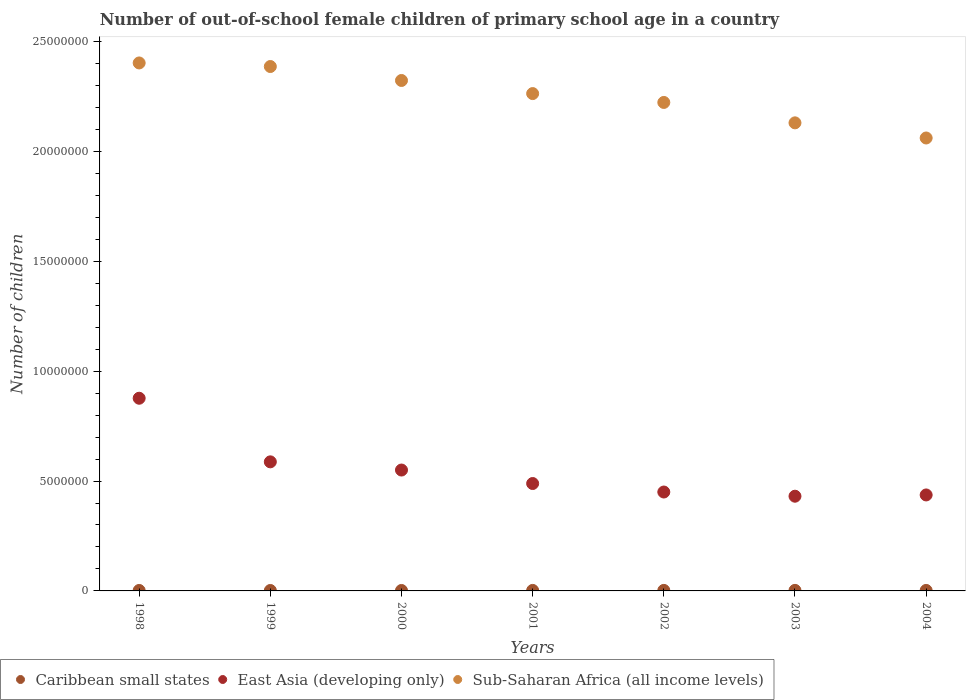How many different coloured dotlines are there?
Keep it short and to the point. 3. What is the number of out-of-school female children in East Asia (developing only) in 1999?
Ensure brevity in your answer.  5.87e+06. Across all years, what is the maximum number of out-of-school female children in Caribbean small states?
Provide a short and direct response. 2.49e+04. Across all years, what is the minimum number of out-of-school female children in Sub-Saharan Africa (all income levels)?
Make the answer very short. 2.06e+07. In which year was the number of out-of-school female children in Caribbean small states maximum?
Provide a succinct answer. 2003. In which year was the number of out-of-school female children in Sub-Saharan Africa (all income levels) minimum?
Your response must be concise. 2004. What is the total number of out-of-school female children in Sub-Saharan Africa (all income levels) in the graph?
Your answer should be very brief. 1.58e+08. What is the difference between the number of out-of-school female children in Sub-Saharan Africa (all income levels) in 2003 and that in 2004?
Your answer should be very brief. 6.89e+05. What is the difference between the number of out-of-school female children in Caribbean small states in 1998 and the number of out-of-school female children in East Asia (developing only) in 2000?
Your response must be concise. -5.48e+06. What is the average number of out-of-school female children in Sub-Saharan Africa (all income levels) per year?
Offer a very short reply. 2.26e+07. In the year 1999, what is the difference between the number of out-of-school female children in Sub-Saharan Africa (all income levels) and number of out-of-school female children in Caribbean small states?
Your response must be concise. 2.38e+07. What is the ratio of the number of out-of-school female children in Sub-Saharan Africa (all income levels) in 1999 to that in 2004?
Ensure brevity in your answer.  1.16. What is the difference between the highest and the second highest number of out-of-school female children in East Asia (developing only)?
Ensure brevity in your answer.  2.89e+06. What is the difference between the highest and the lowest number of out-of-school female children in East Asia (developing only)?
Your response must be concise. 4.46e+06. How many years are there in the graph?
Ensure brevity in your answer.  7. Are the values on the major ticks of Y-axis written in scientific E-notation?
Offer a terse response. No. Does the graph contain any zero values?
Your answer should be compact. No. Where does the legend appear in the graph?
Provide a succinct answer. Bottom left. How many legend labels are there?
Provide a succinct answer. 3. How are the legend labels stacked?
Offer a terse response. Horizontal. What is the title of the graph?
Your answer should be very brief. Number of out-of-school female children of primary school age in a country. Does "Papua New Guinea" appear as one of the legend labels in the graph?
Provide a succinct answer. No. What is the label or title of the Y-axis?
Ensure brevity in your answer.  Number of children. What is the Number of children in Caribbean small states in 1998?
Offer a very short reply. 2.08e+04. What is the Number of children in East Asia (developing only) in 1998?
Your answer should be very brief. 8.77e+06. What is the Number of children of Sub-Saharan Africa (all income levels) in 1998?
Give a very brief answer. 2.40e+07. What is the Number of children of Caribbean small states in 1999?
Your answer should be compact. 1.98e+04. What is the Number of children in East Asia (developing only) in 1999?
Keep it short and to the point. 5.87e+06. What is the Number of children of Sub-Saharan Africa (all income levels) in 1999?
Your answer should be compact. 2.39e+07. What is the Number of children of Caribbean small states in 2000?
Provide a succinct answer. 2.00e+04. What is the Number of children of East Asia (developing only) in 2000?
Ensure brevity in your answer.  5.50e+06. What is the Number of children in Sub-Saharan Africa (all income levels) in 2000?
Provide a succinct answer. 2.32e+07. What is the Number of children of Caribbean small states in 2001?
Give a very brief answer. 2.31e+04. What is the Number of children in East Asia (developing only) in 2001?
Offer a terse response. 4.89e+06. What is the Number of children in Sub-Saharan Africa (all income levels) in 2001?
Your response must be concise. 2.26e+07. What is the Number of children in Caribbean small states in 2002?
Ensure brevity in your answer.  2.41e+04. What is the Number of children in East Asia (developing only) in 2002?
Make the answer very short. 4.50e+06. What is the Number of children of Sub-Saharan Africa (all income levels) in 2002?
Offer a terse response. 2.22e+07. What is the Number of children in Caribbean small states in 2003?
Ensure brevity in your answer.  2.49e+04. What is the Number of children in East Asia (developing only) in 2003?
Provide a succinct answer. 4.31e+06. What is the Number of children in Sub-Saharan Africa (all income levels) in 2003?
Make the answer very short. 2.13e+07. What is the Number of children in Caribbean small states in 2004?
Offer a terse response. 2.23e+04. What is the Number of children of East Asia (developing only) in 2004?
Your answer should be compact. 4.37e+06. What is the Number of children in Sub-Saharan Africa (all income levels) in 2004?
Ensure brevity in your answer.  2.06e+07. Across all years, what is the maximum Number of children of Caribbean small states?
Your response must be concise. 2.49e+04. Across all years, what is the maximum Number of children of East Asia (developing only)?
Provide a succinct answer. 8.77e+06. Across all years, what is the maximum Number of children in Sub-Saharan Africa (all income levels)?
Your answer should be compact. 2.40e+07. Across all years, what is the minimum Number of children of Caribbean small states?
Offer a terse response. 1.98e+04. Across all years, what is the minimum Number of children in East Asia (developing only)?
Provide a succinct answer. 4.31e+06. Across all years, what is the minimum Number of children of Sub-Saharan Africa (all income levels)?
Give a very brief answer. 2.06e+07. What is the total Number of children of Caribbean small states in the graph?
Ensure brevity in your answer.  1.55e+05. What is the total Number of children in East Asia (developing only) in the graph?
Provide a short and direct response. 3.82e+07. What is the total Number of children in Sub-Saharan Africa (all income levels) in the graph?
Offer a very short reply. 1.58e+08. What is the difference between the Number of children of Caribbean small states in 1998 and that in 1999?
Offer a very short reply. 1053. What is the difference between the Number of children of East Asia (developing only) in 1998 and that in 1999?
Provide a short and direct response. 2.89e+06. What is the difference between the Number of children in Sub-Saharan Africa (all income levels) in 1998 and that in 1999?
Provide a short and direct response. 1.62e+05. What is the difference between the Number of children of Caribbean small states in 1998 and that in 2000?
Keep it short and to the point. 776. What is the difference between the Number of children of East Asia (developing only) in 1998 and that in 2000?
Offer a terse response. 3.27e+06. What is the difference between the Number of children of Sub-Saharan Africa (all income levels) in 1998 and that in 2000?
Make the answer very short. 7.98e+05. What is the difference between the Number of children in Caribbean small states in 1998 and that in 2001?
Provide a short and direct response. -2341. What is the difference between the Number of children in East Asia (developing only) in 1998 and that in 2001?
Keep it short and to the point. 3.88e+06. What is the difference between the Number of children in Sub-Saharan Africa (all income levels) in 1998 and that in 2001?
Make the answer very short. 1.39e+06. What is the difference between the Number of children in Caribbean small states in 1998 and that in 2002?
Your answer should be very brief. -3301. What is the difference between the Number of children in East Asia (developing only) in 1998 and that in 2002?
Your answer should be compact. 4.27e+06. What is the difference between the Number of children of Sub-Saharan Africa (all income levels) in 1998 and that in 2002?
Make the answer very short. 1.80e+06. What is the difference between the Number of children in Caribbean small states in 1998 and that in 2003?
Provide a succinct answer. -4129. What is the difference between the Number of children of East Asia (developing only) in 1998 and that in 2003?
Provide a succinct answer. 4.46e+06. What is the difference between the Number of children in Sub-Saharan Africa (all income levels) in 1998 and that in 2003?
Your answer should be compact. 2.73e+06. What is the difference between the Number of children in Caribbean small states in 1998 and that in 2004?
Make the answer very short. -1502. What is the difference between the Number of children in East Asia (developing only) in 1998 and that in 2004?
Provide a short and direct response. 4.40e+06. What is the difference between the Number of children in Sub-Saharan Africa (all income levels) in 1998 and that in 2004?
Ensure brevity in your answer.  3.41e+06. What is the difference between the Number of children of Caribbean small states in 1999 and that in 2000?
Your response must be concise. -277. What is the difference between the Number of children of East Asia (developing only) in 1999 and that in 2000?
Provide a short and direct response. 3.73e+05. What is the difference between the Number of children of Sub-Saharan Africa (all income levels) in 1999 and that in 2000?
Your answer should be very brief. 6.35e+05. What is the difference between the Number of children in Caribbean small states in 1999 and that in 2001?
Offer a terse response. -3394. What is the difference between the Number of children of East Asia (developing only) in 1999 and that in 2001?
Make the answer very short. 9.86e+05. What is the difference between the Number of children of Sub-Saharan Africa (all income levels) in 1999 and that in 2001?
Make the answer very short. 1.23e+06. What is the difference between the Number of children in Caribbean small states in 1999 and that in 2002?
Offer a very short reply. -4354. What is the difference between the Number of children of East Asia (developing only) in 1999 and that in 2002?
Offer a very short reply. 1.37e+06. What is the difference between the Number of children of Sub-Saharan Africa (all income levels) in 1999 and that in 2002?
Offer a terse response. 1.63e+06. What is the difference between the Number of children in Caribbean small states in 1999 and that in 2003?
Provide a succinct answer. -5182. What is the difference between the Number of children in East Asia (developing only) in 1999 and that in 2003?
Offer a very short reply. 1.56e+06. What is the difference between the Number of children of Sub-Saharan Africa (all income levels) in 1999 and that in 2003?
Offer a terse response. 2.56e+06. What is the difference between the Number of children in Caribbean small states in 1999 and that in 2004?
Provide a succinct answer. -2555. What is the difference between the Number of children in East Asia (developing only) in 1999 and that in 2004?
Ensure brevity in your answer.  1.51e+06. What is the difference between the Number of children in Sub-Saharan Africa (all income levels) in 1999 and that in 2004?
Your answer should be very brief. 3.25e+06. What is the difference between the Number of children of Caribbean small states in 2000 and that in 2001?
Give a very brief answer. -3117. What is the difference between the Number of children in East Asia (developing only) in 2000 and that in 2001?
Provide a succinct answer. 6.14e+05. What is the difference between the Number of children in Sub-Saharan Africa (all income levels) in 2000 and that in 2001?
Make the answer very short. 5.96e+05. What is the difference between the Number of children in Caribbean small states in 2000 and that in 2002?
Make the answer very short. -4077. What is the difference between the Number of children in East Asia (developing only) in 2000 and that in 2002?
Offer a very short reply. 1.00e+06. What is the difference between the Number of children of Sub-Saharan Africa (all income levels) in 2000 and that in 2002?
Offer a terse response. 9.99e+05. What is the difference between the Number of children in Caribbean small states in 2000 and that in 2003?
Offer a very short reply. -4905. What is the difference between the Number of children of East Asia (developing only) in 2000 and that in 2003?
Your response must be concise. 1.19e+06. What is the difference between the Number of children of Sub-Saharan Africa (all income levels) in 2000 and that in 2003?
Provide a short and direct response. 1.93e+06. What is the difference between the Number of children in Caribbean small states in 2000 and that in 2004?
Offer a terse response. -2278. What is the difference between the Number of children of East Asia (developing only) in 2000 and that in 2004?
Keep it short and to the point. 1.13e+06. What is the difference between the Number of children of Sub-Saharan Africa (all income levels) in 2000 and that in 2004?
Offer a very short reply. 2.62e+06. What is the difference between the Number of children of Caribbean small states in 2001 and that in 2002?
Provide a short and direct response. -960. What is the difference between the Number of children in East Asia (developing only) in 2001 and that in 2002?
Provide a succinct answer. 3.87e+05. What is the difference between the Number of children of Sub-Saharan Africa (all income levels) in 2001 and that in 2002?
Make the answer very short. 4.03e+05. What is the difference between the Number of children in Caribbean small states in 2001 and that in 2003?
Keep it short and to the point. -1788. What is the difference between the Number of children in East Asia (developing only) in 2001 and that in 2003?
Ensure brevity in your answer.  5.78e+05. What is the difference between the Number of children in Sub-Saharan Africa (all income levels) in 2001 and that in 2003?
Offer a very short reply. 1.33e+06. What is the difference between the Number of children in Caribbean small states in 2001 and that in 2004?
Offer a very short reply. 839. What is the difference between the Number of children in East Asia (developing only) in 2001 and that in 2004?
Offer a terse response. 5.20e+05. What is the difference between the Number of children of Sub-Saharan Africa (all income levels) in 2001 and that in 2004?
Ensure brevity in your answer.  2.02e+06. What is the difference between the Number of children of Caribbean small states in 2002 and that in 2003?
Offer a very short reply. -828. What is the difference between the Number of children in East Asia (developing only) in 2002 and that in 2003?
Make the answer very short. 1.91e+05. What is the difference between the Number of children in Sub-Saharan Africa (all income levels) in 2002 and that in 2003?
Provide a succinct answer. 9.28e+05. What is the difference between the Number of children in Caribbean small states in 2002 and that in 2004?
Make the answer very short. 1799. What is the difference between the Number of children in East Asia (developing only) in 2002 and that in 2004?
Your answer should be very brief. 1.33e+05. What is the difference between the Number of children in Sub-Saharan Africa (all income levels) in 2002 and that in 2004?
Make the answer very short. 1.62e+06. What is the difference between the Number of children of Caribbean small states in 2003 and that in 2004?
Provide a short and direct response. 2627. What is the difference between the Number of children of East Asia (developing only) in 2003 and that in 2004?
Keep it short and to the point. -5.77e+04. What is the difference between the Number of children of Sub-Saharan Africa (all income levels) in 2003 and that in 2004?
Offer a terse response. 6.89e+05. What is the difference between the Number of children in Caribbean small states in 1998 and the Number of children in East Asia (developing only) in 1999?
Ensure brevity in your answer.  -5.85e+06. What is the difference between the Number of children of Caribbean small states in 1998 and the Number of children of Sub-Saharan Africa (all income levels) in 1999?
Offer a terse response. -2.38e+07. What is the difference between the Number of children in East Asia (developing only) in 1998 and the Number of children in Sub-Saharan Africa (all income levels) in 1999?
Make the answer very short. -1.51e+07. What is the difference between the Number of children in Caribbean small states in 1998 and the Number of children in East Asia (developing only) in 2000?
Keep it short and to the point. -5.48e+06. What is the difference between the Number of children in Caribbean small states in 1998 and the Number of children in Sub-Saharan Africa (all income levels) in 2000?
Make the answer very short. -2.32e+07. What is the difference between the Number of children in East Asia (developing only) in 1998 and the Number of children in Sub-Saharan Africa (all income levels) in 2000?
Your response must be concise. -1.45e+07. What is the difference between the Number of children in Caribbean small states in 1998 and the Number of children in East Asia (developing only) in 2001?
Your answer should be very brief. -4.87e+06. What is the difference between the Number of children in Caribbean small states in 1998 and the Number of children in Sub-Saharan Africa (all income levels) in 2001?
Keep it short and to the point. -2.26e+07. What is the difference between the Number of children of East Asia (developing only) in 1998 and the Number of children of Sub-Saharan Africa (all income levels) in 2001?
Provide a succinct answer. -1.39e+07. What is the difference between the Number of children of Caribbean small states in 1998 and the Number of children of East Asia (developing only) in 2002?
Your answer should be compact. -4.48e+06. What is the difference between the Number of children in Caribbean small states in 1998 and the Number of children in Sub-Saharan Africa (all income levels) in 2002?
Give a very brief answer. -2.22e+07. What is the difference between the Number of children in East Asia (developing only) in 1998 and the Number of children in Sub-Saharan Africa (all income levels) in 2002?
Ensure brevity in your answer.  -1.35e+07. What is the difference between the Number of children in Caribbean small states in 1998 and the Number of children in East Asia (developing only) in 2003?
Offer a very short reply. -4.29e+06. What is the difference between the Number of children in Caribbean small states in 1998 and the Number of children in Sub-Saharan Africa (all income levels) in 2003?
Your answer should be compact. -2.13e+07. What is the difference between the Number of children of East Asia (developing only) in 1998 and the Number of children of Sub-Saharan Africa (all income levels) in 2003?
Ensure brevity in your answer.  -1.25e+07. What is the difference between the Number of children in Caribbean small states in 1998 and the Number of children in East Asia (developing only) in 2004?
Your response must be concise. -4.35e+06. What is the difference between the Number of children of Caribbean small states in 1998 and the Number of children of Sub-Saharan Africa (all income levels) in 2004?
Ensure brevity in your answer.  -2.06e+07. What is the difference between the Number of children in East Asia (developing only) in 1998 and the Number of children in Sub-Saharan Africa (all income levels) in 2004?
Your answer should be very brief. -1.18e+07. What is the difference between the Number of children in Caribbean small states in 1999 and the Number of children in East Asia (developing only) in 2000?
Offer a very short reply. -5.48e+06. What is the difference between the Number of children of Caribbean small states in 1999 and the Number of children of Sub-Saharan Africa (all income levels) in 2000?
Offer a very short reply. -2.32e+07. What is the difference between the Number of children of East Asia (developing only) in 1999 and the Number of children of Sub-Saharan Africa (all income levels) in 2000?
Your response must be concise. -1.74e+07. What is the difference between the Number of children of Caribbean small states in 1999 and the Number of children of East Asia (developing only) in 2001?
Provide a short and direct response. -4.87e+06. What is the difference between the Number of children of Caribbean small states in 1999 and the Number of children of Sub-Saharan Africa (all income levels) in 2001?
Your answer should be very brief. -2.26e+07. What is the difference between the Number of children of East Asia (developing only) in 1999 and the Number of children of Sub-Saharan Africa (all income levels) in 2001?
Make the answer very short. -1.68e+07. What is the difference between the Number of children in Caribbean small states in 1999 and the Number of children in East Asia (developing only) in 2002?
Offer a very short reply. -4.48e+06. What is the difference between the Number of children in Caribbean small states in 1999 and the Number of children in Sub-Saharan Africa (all income levels) in 2002?
Ensure brevity in your answer.  -2.22e+07. What is the difference between the Number of children in East Asia (developing only) in 1999 and the Number of children in Sub-Saharan Africa (all income levels) in 2002?
Make the answer very short. -1.64e+07. What is the difference between the Number of children in Caribbean small states in 1999 and the Number of children in East Asia (developing only) in 2003?
Offer a terse response. -4.29e+06. What is the difference between the Number of children in Caribbean small states in 1999 and the Number of children in Sub-Saharan Africa (all income levels) in 2003?
Provide a succinct answer. -2.13e+07. What is the difference between the Number of children in East Asia (developing only) in 1999 and the Number of children in Sub-Saharan Africa (all income levels) in 2003?
Your response must be concise. -1.54e+07. What is the difference between the Number of children in Caribbean small states in 1999 and the Number of children in East Asia (developing only) in 2004?
Your answer should be compact. -4.35e+06. What is the difference between the Number of children of Caribbean small states in 1999 and the Number of children of Sub-Saharan Africa (all income levels) in 2004?
Your answer should be very brief. -2.06e+07. What is the difference between the Number of children in East Asia (developing only) in 1999 and the Number of children in Sub-Saharan Africa (all income levels) in 2004?
Ensure brevity in your answer.  -1.47e+07. What is the difference between the Number of children in Caribbean small states in 2000 and the Number of children in East Asia (developing only) in 2001?
Provide a succinct answer. -4.87e+06. What is the difference between the Number of children in Caribbean small states in 2000 and the Number of children in Sub-Saharan Africa (all income levels) in 2001?
Ensure brevity in your answer.  -2.26e+07. What is the difference between the Number of children of East Asia (developing only) in 2000 and the Number of children of Sub-Saharan Africa (all income levels) in 2001?
Your answer should be very brief. -1.71e+07. What is the difference between the Number of children of Caribbean small states in 2000 and the Number of children of East Asia (developing only) in 2002?
Provide a short and direct response. -4.48e+06. What is the difference between the Number of children in Caribbean small states in 2000 and the Number of children in Sub-Saharan Africa (all income levels) in 2002?
Provide a succinct answer. -2.22e+07. What is the difference between the Number of children of East Asia (developing only) in 2000 and the Number of children of Sub-Saharan Africa (all income levels) in 2002?
Your answer should be very brief. -1.67e+07. What is the difference between the Number of children of Caribbean small states in 2000 and the Number of children of East Asia (developing only) in 2003?
Keep it short and to the point. -4.29e+06. What is the difference between the Number of children of Caribbean small states in 2000 and the Number of children of Sub-Saharan Africa (all income levels) in 2003?
Give a very brief answer. -2.13e+07. What is the difference between the Number of children in East Asia (developing only) in 2000 and the Number of children in Sub-Saharan Africa (all income levels) in 2003?
Ensure brevity in your answer.  -1.58e+07. What is the difference between the Number of children of Caribbean small states in 2000 and the Number of children of East Asia (developing only) in 2004?
Keep it short and to the point. -4.35e+06. What is the difference between the Number of children in Caribbean small states in 2000 and the Number of children in Sub-Saharan Africa (all income levels) in 2004?
Keep it short and to the point. -2.06e+07. What is the difference between the Number of children in East Asia (developing only) in 2000 and the Number of children in Sub-Saharan Africa (all income levels) in 2004?
Provide a succinct answer. -1.51e+07. What is the difference between the Number of children of Caribbean small states in 2001 and the Number of children of East Asia (developing only) in 2002?
Your response must be concise. -4.48e+06. What is the difference between the Number of children of Caribbean small states in 2001 and the Number of children of Sub-Saharan Africa (all income levels) in 2002?
Provide a succinct answer. -2.22e+07. What is the difference between the Number of children of East Asia (developing only) in 2001 and the Number of children of Sub-Saharan Africa (all income levels) in 2002?
Keep it short and to the point. -1.73e+07. What is the difference between the Number of children in Caribbean small states in 2001 and the Number of children in East Asia (developing only) in 2003?
Make the answer very short. -4.29e+06. What is the difference between the Number of children in Caribbean small states in 2001 and the Number of children in Sub-Saharan Africa (all income levels) in 2003?
Make the answer very short. -2.13e+07. What is the difference between the Number of children in East Asia (developing only) in 2001 and the Number of children in Sub-Saharan Africa (all income levels) in 2003?
Keep it short and to the point. -1.64e+07. What is the difference between the Number of children in Caribbean small states in 2001 and the Number of children in East Asia (developing only) in 2004?
Offer a terse response. -4.34e+06. What is the difference between the Number of children in Caribbean small states in 2001 and the Number of children in Sub-Saharan Africa (all income levels) in 2004?
Ensure brevity in your answer.  -2.06e+07. What is the difference between the Number of children of East Asia (developing only) in 2001 and the Number of children of Sub-Saharan Africa (all income levels) in 2004?
Make the answer very short. -1.57e+07. What is the difference between the Number of children of Caribbean small states in 2002 and the Number of children of East Asia (developing only) in 2003?
Ensure brevity in your answer.  -4.28e+06. What is the difference between the Number of children of Caribbean small states in 2002 and the Number of children of Sub-Saharan Africa (all income levels) in 2003?
Offer a very short reply. -2.13e+07. What is the difference between the Number of children in East Asia (developing only) in 2002 and the Number of children in Sub-Saharan Africa (all income levels) in 2003?
Offer a very short reply. -1.68e+07. What is the difference between the Number of children in Caribbean small states in 2002 and the Number of children in East Asia (developing only) in 2004?
Your answer should be very brief. -4.34e+06. What is the difference between the Number of children of Caribbean small states in 2002 and the Number of children of Sub-Saharan Africa (all income levels) in 2004?
Offer a terse response. -2.06e+07. What is the difference between the Number of children of East Asia (developing only) in 2002 and the Number of children of Sub-Saharan Africa (all income levels) in 2004?
Provide a short and direct response. -1.61e+07. What is the difference between the Number of children in Caribbean small states in 2003 and the Number of children in East Asia (developing only) in 2004?
Ensure brevity in your answer.  -4.34e+06. What is the difference between the Number of children in Caribbean small states in 2003 and the Number of children in Sub-Saharan Africa (all income levels) in 2004?
Your response must be concise. -2.06e+07. What is the difference between the Number of children of East Asia (developing only) in 2003 and the Number of children of Sub-Saharan Africa (all income levels) in 2004?
Keep it short and to the point. -1.63e+07. What is the average Number of children of Caribbean small states per year?
Keep it short and to the point. 2.22e+04. What is the average Number of children in East Asia (developing only) per year?
Provide a succinct answer. 5.46e+06. What is the average Number of children of Sub-Saharan Africa (all income levels) per year?
Your answer should be compact. 2.26e+07. In the year 1998, what is the difference between the Number of children in Caribbean small states and Number of children in East Asia (developing only)?
Ensure brevity in your answer.  -8.75e+06. In the year 1998, what is the difference between the Number of children of Caribbean small states and Number of children of Sub-Saharan Africa (all income levels)?
Make the answer very short. -2.40e+07. In the year 1998, what is the difference between the Number of children in East Asia (developing only) and Number of children in Sub-Saharan Africa (all income levels)?
Provide a succinct answer. -1.53e+07. In the year 1999, what is the difference between the Number of children in Caribbean small states and Number of children in East Asia (developing only)?
Ensure brevity in your answer.  -5.85e+06. In the year 1999, what is the difference between the Number of children of Caribbean small states and Number of children of Sub-Saharan Africa (all income levels)?
Give a very brief answer. -2.38e+07. In the year 1999, what is the difference between the Number of children in East Asia (developing only) and Number of children in Sub-Saharan Africa (all income levels)?
Give a very brief answer. -1.80e+07. In the year 2000, what is the difference between the Number of children of Caribbean small states and Number of children of East Asia (developing only)?
Ensure brevity in your answer.  -5.48e+06. In the year 2000, what is the difference between the Number of children in Caribbean small states and Number of children in Sub-Saharan Africa (all income levels)?
Offer a terse response. -2.32e+07. In the year 2000, what is the difference between the Number of children of East Asia (developing only) and Number of children of Sub-Saharan Africa (all income levels)?
Keep it short and to the point. -1.77e+07. In the year 2001, what is the difference between the Number of children in Caribbean small states and Number of children in East Asia (developing only)?
Offer a terse response. -4.86e+06. In the year 2001, what is the difference between the Number of children of Caribbean small states and Number of children of Sub-Saharan Africa (all income levels)?
Provide a succinct answer. -2.26e+07. In the year 2001, what is the difference between the Number of children of East Asia (developing only) and Number of children of Sub-Saharan Africa (all income levels)?
Provide a short and direct response. -1.77e+07. In the year 2002, what is the difference between the Number of children in Caribbean small states and Number of children in East Asia (developing only)?
Offer a very short reply. -4.48e+06. In the year 2002, what is the difference between the Number of children of Caribbean small states and Number of children of Sub-Saharan Africa (all income levels)?
Your response must be concise. -2.22e+07. In the year 2002, what is the difference between the Number of children in East Asia (developing only) and Number of children in Sub-Saharan Africa (all income levels)?
Your answer should be compact. -1.77e+07. In the year 2003, what is the difference between the Number of children of Caribbean small states and Number of children of East Asia (developing only)?
Your response must be concise. -4.28e+06. In the year 2003, what is the difference between the Number of children in Caribbean small states and Number of children in Sub-Saharan Africa (all income levels)?
Your answer should be very brief. -2.13e+07. In the year 2003, what is the difference between the Number of children in East Asia (developing only) and Number of children in Sub-Saharan Africa (all income levels)?
Give a very brief answer. -1.70e+07. In the year 2004, what is the difference between the Number of children in Caribbean small states and Number of children in East Asia (developing only)?
Your answer should be compact. -4.34e+06. In the year 2004, what is the difference between the Number of children of Caribbean small states and Number of children of Sub-Saharan Africa (all income levels)?
Make the answer very short. -2.06e+07. In the year 2004, what is the difference between the Number of children of East Asia (developing only) and Number of children of Sub-Saharan Africa (all income levels)?
Give a very brief answer. -1.62e+07. What is the ratio of the Number of children in Caribbean small states in 1998 to that in 1999?
Make the answer very short. 1.05. What is the ratio of the Number of children of East Asia (developing only) in 1998 to that in 1999?
Offer a terse response. 1.49. What is the ratio of the Number of children in Sub-Saharan Africa (all income levels) in 1998 to that in 1999?
Give a very brief answer. 1.01. What is the ratio of the Number of children in Caribbean small states in 1998 to that in 2000?
Ensure brevity in your answer.  1.04. What is the ratio of the Number of children in East Asia (developing only) in 1998 to that in 2000?
Your answer should be compact. 1.59. What is the ratio of the Number of children in Sub-Saharan Africa (all income levels) in 1998 to that in 2000?
Ensure brevity in your answer.  1.03. What is the ratio of the Number of children of Caribbean small states in 1998 to that in 2001?
Give a very brief answer. 0.9. What is the ratio of the Number of children in East Asia (developing only) in 1998 to that in 2001?
Make the answer very short. 1.79. What is the ratio of the Number of children of Sub-Saharan Africa (all income levels) in 1998 to that in 2001?
Keep it short and to the point. 1.06. What is the ratio of the Number of children in Caribbean small states in 1998 to that in 2002?
Ensure brevity in your answer.  0.86. What is the ratio of the Number of children in East Asia (developing only) in 1998 to that in 2002?
Your response must be concise. 1.95. What is the ratio of the Number of children in Sub-Saharan Africa (all income levels) in 1998 to that in 2002?
Offer a very short reply. 1.08. What is the ratio of the Number of children of Caribbean small states in 1998 to that in 2003?
Provide a short and direct response. 0.83. What is the ratio of the Number of children of East Asia (developing only) in 1998 to that in 2003?
Ensure brevity in your answer.  2.03. What is the ratio of the Number of children of Sub-Saharan Africa (all income levels) in 1998 to that in 2003?
Provide a short and direct response. 1.13. What is the ratio of the Number of children of Caribbean small states in 1998 to that in 2004?
Offer a very short reply. 0.93. What is the ratio of the Number of children of East Asia (developing only) in 1998 to that in 2004?
Offer a terse response. 2.01. What is the ratio of the Number of children of Sub-Saharan Africa (all income levels) in 1998 to that in 2004?
Ensure brevity in your answer.  1.17. What is the ratio of the Number of children in Caribbean small states in 1999 to that in 2000?
Your response must be concise. 0.99. What is the ratio of the Number of children of East Asia (developing only) in 1999 to that in 2000?
Your answer should be very brief. 1.07. What is the ratio of the Number of children in Sub-Saharan Africa (all income levels) in 1999 to that in 2000?
Provide a short and direct response. 1.03. What is the ratio of the Number of children in Caribbean small states in 1999 to that in 2001?
Your response must be concise. 0.85. What is the ratio of the Number of children in East Asia (developing only) in 1999 to that in 2001?
Your response must be concise. 1.2. What is the ratio of the Number of children in Sub-Saharan Africa (all income levels) in 1999 to that in 2001?
Keep it short and to the point. 1.05. What is the ratio of the Number of children in Caribbean small states in 1999 to that in 2002?
Make the answer very short. 0.82. What is the ratio of the Number of children of East Asia (developing only) in 1999 to that in 2002?
Provide a succinct answer. 1.31. What is the ratio of the Number of children in Sub-Saharan Africa (all income levels) in 1999 to that in 2002?
Keep it short and to the point. 1.07. What is the ratio of the Number of children of Caribbean small states in 1999 to that in 2003?
Your answer should be very brief. 0.79. What is the ratio of the Number of children in East Asia (developing only) in 1999 to that in 2003?
Keep it short and to the point. 1.36. What is the ratio of the Number of children in Sub-Saharan Africa (all income levels) in 1999 to that in 2003?
Your response must be concise. 1.12. What is the ratio of the Number of children in Caribbean small states in 1999 to that in 2004?
Ensure brevity in your answer.  0.89. What is the ratio of the Number of children in East Asia (developing only) in 1999 to that in 2004?
Offer a very short reply. 1.34. What is the ratio of the Number of children of Sub-Saharan Africa (all income levels) in 1999 to that in 2004?
Your response must be concise. 1.16. What is the ratio of the Number of children of Caribbean small states in 2000 to that in 2001?
Give a very brief answer. 0.87. What is the ratio of the Number of children of East Asia (developing only) in 2000 to that in 2001?
Provide a succinct answer. 1.13. What is the ratio of the Number of children of Sub-Saharan Africa (all income levels) in 2000 to that in 2001?
Provide a short and direct response. 1.03. What is the ratio of the Number of children in Caribbean small states in 2000 to that in 2002?
Provide a short and direct response. 0.83. What is the ratio of the Number of children in East Asia (developing only) in 2000 to that in 2002?
Your response must be concise. 1.22. What is the ratio of the Number of children in Sub-Saharan Africa (all income levels) in 2000 to that in 2002?
Your response must be concise. 1.04. What is the ratio of the Number of children of Caribbean small states in 2000 to that in 2003?
Your answer should be compact. 0.8. What is the ratio of the Number of children in East Asia (developing only) in 2000 to that in 2003?
Your answer should be compact. 1.28. What is the ratio of the Number of children in Sub-Saharan Africa (all income levels) in 2000 to that in 2003?
Offer a terse response. 1.09. What is the ratio of the Number of children in Caribbean small states in 2000 to that in 2004?
Your answer should be compact. 0.9. What is the ratio of the Number of children of East Asia (developing only) in 2000 to that in 2004?
Your answer should be compact. 1.26. What is the ratio of the Number of children of Sub-Saharan Africa (all income levels) in 2000 to that in 2004?
Keep it short and to the point. 1.13. What is the ratio of the Number of children of Caribbean small states in 2001 to that in 2002?
Provide a succinct answer. 0.96. What is the ratio of the Number of children of East Asia (developing only) in 2001 to that in 2002?
Give a very brief answer. 1.09. What is the ratio of the Number of children in Sub-Saharan Africa (all income levels) in 2001 to that in 2002?
Keep it short and to the point. 1.02. What is the ratio of the Number of children of Caribbean small states in 2001 to that in 2003?
Your answer should be compact. 0.93. What is the ratio of the Number of children of East Asia (developing only) in 2001 to that in 2003?
Offer a very short reply. 1.13. What is the ratio of the Number of children in Caribbean small states in 2001 to that in 2004?
Provide a short and direct response. 1.04. What is the ratio of the Number of children in East Asia (developing only) in 2001 to that in 2004?
Keep it short and to the point. 1.12. What is the ratio of the Number of children in Sub-Saharan Africa (all income levels) in 2001 to that in 2004?
Ensure brevity in your answer.  1.1. What is the ratio of the Number of children of Caribbean small states in 2002 to that in 2003?
Offer a very short reply. 0.97. What is the ratio of the Number of children in East Asia (developing only) in 2002 to that in 2003?
Give a very brief answer. 1.04. What is the ratio of the Number of children of Sub-Saharan Africa (all income levels) in 2002 to that in 2003?
Offer a very short reply. 1.04. What is the ratio of the Number of children in Caribbean small states in 2002 to that in 2004?
Offer a very short reply. 1.08. What is the ratio of the Number of children in East Asia (developing only) in 2002 to that in 2004?
Make the answer very short. 1.03. What is the ratio of the Number of children in Sub-Saharan Africa (all income levels) in 2002 to that in 2004?
Give a very brief answer. 1.08. What is the ratio of the Number of children in Caribbean small states in 2003 to that in 2004?
Provide a short and direct response. 1.12. What is the ratio of the Number of children of East Asia (developing only) in 2003 to that in 2004?
Provide a short and direct response. 0.99. What is the ratio of the Number of children of Sub-Saharan Africa (all income levels) in 2003 to that in 2004?
Give a very brief answer. 1.03. What is the difference between the highest and the second highest Number of children in Caribbean small states?
Your response must be concise. 828. What is the difference between the highest and the second highest Number of children of East Asia (developing only)?
Make the answer very short. 2.89e+06. What is the difference between the highest and the second highest Number of children of Sub-Saharan Africa (all income levels)?
Keep it short and to the point. 1.62e+05. What is the difference between the highest and the lowest Number of children in Caribbean small states?
Provide a succinct answer. 5182. What is the difference between the highest and the lowest Number of children in East Asia (developing only)?
Your answer should be compact. 4.46e+06. What is the difference between the highest and the lowest Number of children in Sub-Saharan Africa (all income levels)?
Offer a very short reply. 3.41e+06. 